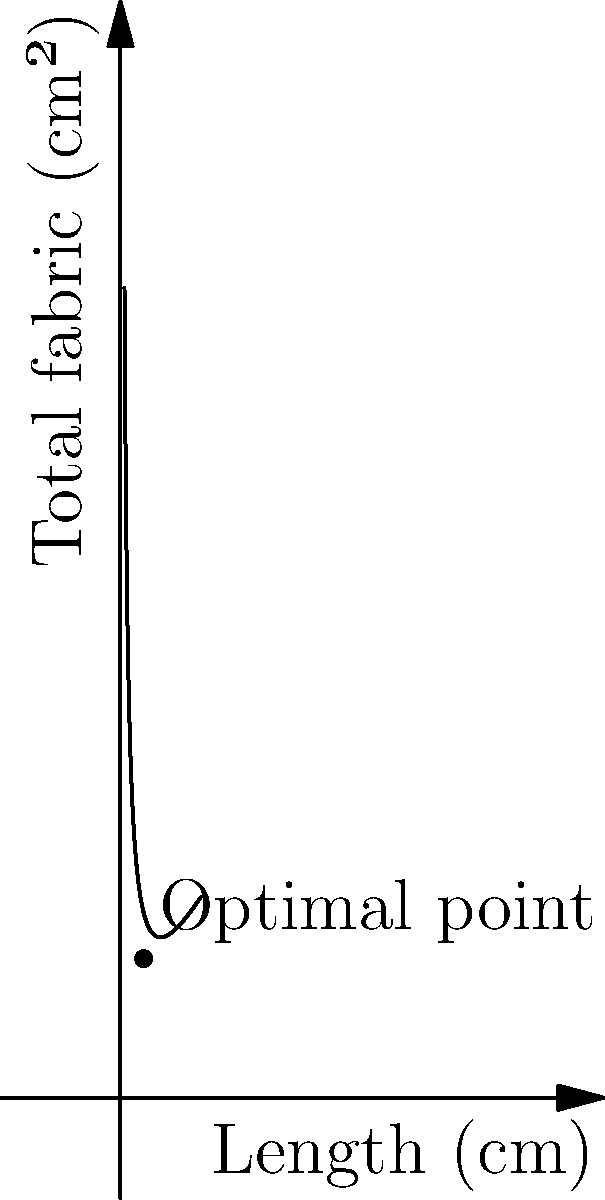A clothing manufacturer wants to create a rectangular storage box with a volume of 1000 cm³. The box requires fabric for the top, bottom, and four sides. If the width of the box is fixed at 10 cm, what should be the length and height of the box to minimize the amount of fabric used? Round your answer to the nearest centimeter. Let's approach this step-by-step:

1) Let $x$ be the length and $y$ be the height of the box.

2) Given:
   - Volume = 1000 cm³
   - Width = 10 cm
   - Volume formula: $V = l * w * h$

3) We can express $y$ in terms of $x$:
   $1000 = 10x * y$
   $y = \frac{100}{x}$

4) The surface area (fabric needed) is:
   $A = 2lw + 2lh + 2wh$
   $A = 2(10x) + 2(x * \frac{100}{x}) + 2(10 * \frac{100}{x})$
   $A = 20x + 200 + \frac{2000}{x}$

5) Simplify:
   $A = 20x + \frac{2000}{x} + 200$

6) To find the minimum, we differentiate and set to zero:
   $\frac{dA}{dx} = 20 - \frac{2000}{x^2} = 0$

7) Solve:
   $20 = \frac{2000}{x^2}$
   $x^2 = 100$
   $x = 10$ (we take the positive root)

8) Calculate $y$:
   $y = \frac{100}{x} = \frac{100}{10} = 10$

Therefore, the optimal dimensions are:
Length (x) = 10 cm
Height (y) = 10 cm
Answer: Length: 10 cm, Height: 10 cm 